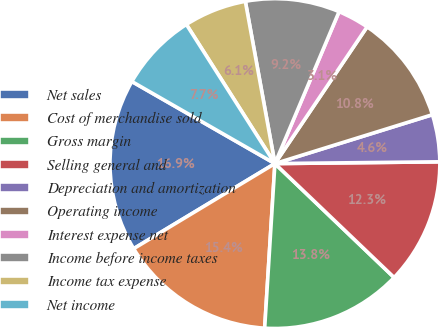Convert chart. <chart><loc_0><loc_0><loc_500><loc_500><pie_chart><fcel>Net sales<fcel>Cost of merchandise sold<fcel>Gross margin<fcel>Selling general and<fcel>Depreciation and amortization<fcel>Operating income<fcel>Interest expense net<fcel>Income before income taxes<fcel>Income tax expense<fcel>Net income<nl><fcel>16.92%<fcel>15.38%<fcel>13.85%<fcel>12.31%<fcel>4.62%<fcel>10.77%<fcel>3.08%<fcel>9.23%<fcel>6.15%<fcel>7.69%<nl></chart> 